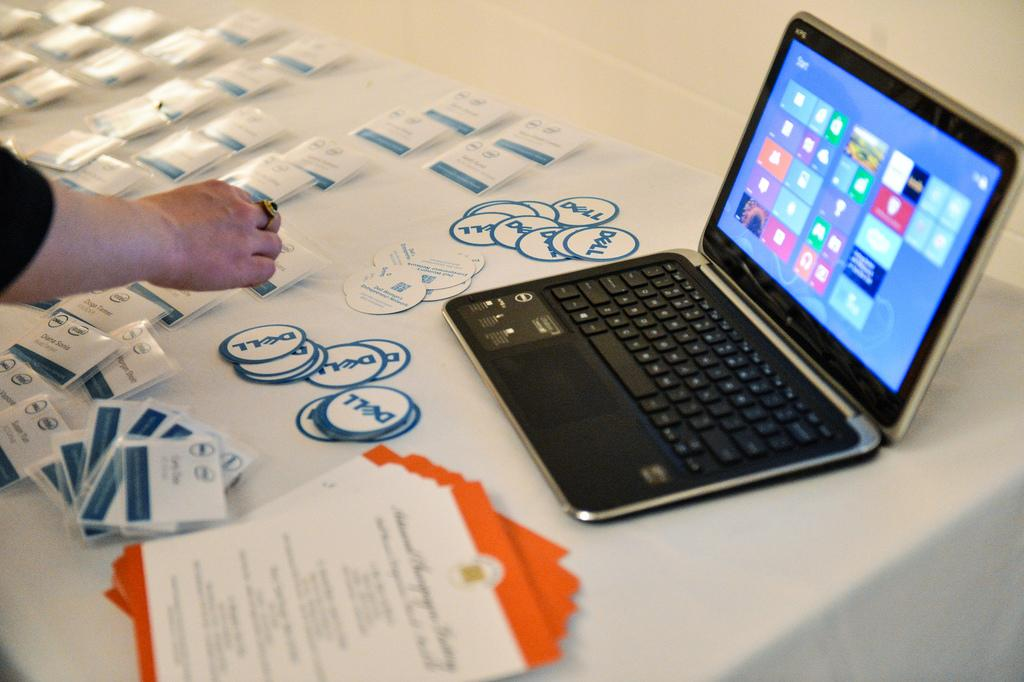<image>
Summarize the visual content of the image. Dell is the company that is setting up for an event. 